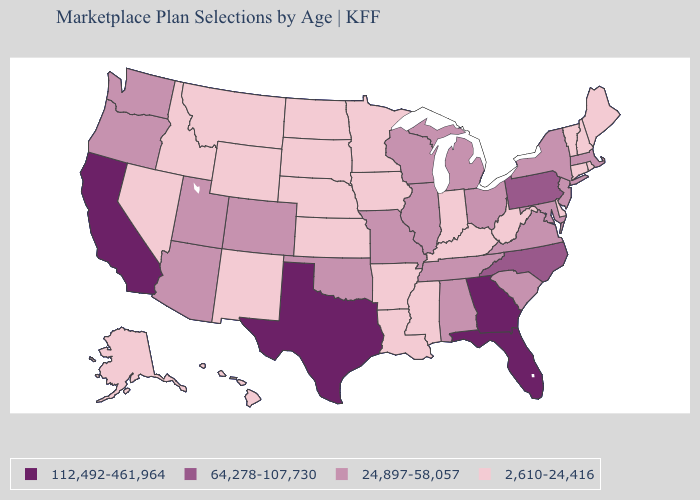What is the lowest value in the South?
Short answer required. 2,610-24,416. Does New Jersey have the lowest value in the USA?
Quick response, please. No. Is the legend a continuous bar?
Short answer required. No. What is the value of Alabama?
Write a very short answer. 24,897-58,057. Which states have the lowest value in the USA?
Concise answer only. Alaska, Arkansas, Connecticut, Delaware, Hawaii, Idaho, Indiana, Iowa, Kansas, Kentucky, Louisiana, Maine, Minnesota, Mississippi, Montana, Nebraska, Nevada, New Hampshire, New Mexico, North Dakota, Rhode Island, South Dakota, Vermont, West Virginia, Wyoming. Name the states that have a value in the range 64,278-107,730?
Concise answer only. North Carolina, Pennsylvania. Which states have the highest value in the USA?
Answer briefly. California, Florida, Georgia, Texas. Which states have the highest value in the USA?
Concise answer only. California, Florida, Georgia, Texas. Name the states that have a value in the range 2,610-24,416?
Quick response, please. Alaska, Arkansas, Connecticut, Delaware, Hawaii, Idaho, Indiana, Iowa, Kansas, Kentucky, Louisiana, Maine, Minnesota, Mississippi, Montana, Nebraska, Nevada, New Hampshire, New Mexico, North Dakota, Rhode Island, South Dakota, Vermont, West Virginia, Wyoming. Name the states that have a value in the range 64,278-107,730?
Concise answer only. North Carolina, Pennsylvania. Among the states that border New Mexico , does Texas have the highest value?
Keep it brief. Yes. What is the value of Mississippi?
Concise answer only. 2,610-24,416. What is the highest value in the South ?
Keep it brief. 112,492-461,964. Which states hav the highest value in the West?
Be succinct. California. Name the states that have a value in the range 2,610-24,416?
Short answer required. Alaska, Arkansas, Connecticut, Delaware, Hawaii, Idaho, Indiana, Iowa, Kansas, Kentucky, Louisiana, Maine, Minnesota, Mississippi, Montana, Nebraska, Nevada, New Hampshire, New Mexico, North Dakota, Rhode Island, South Dakota, Vermont, West Virginia, Wyoming. 